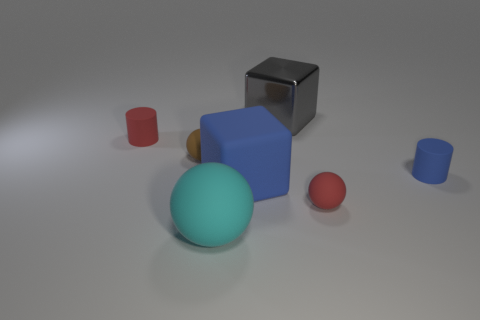Is the number of blue rubber cubes left of the small brown matte thing greater than the number of small blue things?
Your response must be concise. No. Are any cyan rubber cylinders visible?
Make the answer very short. No. There is a tiny rubber thing in front of the large blue rubber cube; what is its color?
Keep it short and to the point. Red. What material is the other cylinder that is the same size as the red cylinder?
Make the answer very short. Rubber. What number of other things are made of the same material as the gray object?
Ensure brevity in your answer.  0. There is a rubber ball that is in front of the tiny blue cylinder and left of the metal object; what is its color?
Offer a very short reply. Cyan. What number of things are tiny red matte objects that are to the right of the gray shiny block or big metallic spheres?
Offer a terse response. 1. What number of other objects are there of the same color as the matte block?
Provide a short and direct response. 1. Is the number of rubber things in front of the brown ball the same as the number of red spheres?
Your answer should be compact. No. How many tiny red matte objects are in front of the tiny matte cylinder left of the small cylinder that is right of the large gray shiny block?
Give a very brief answer. 1. 